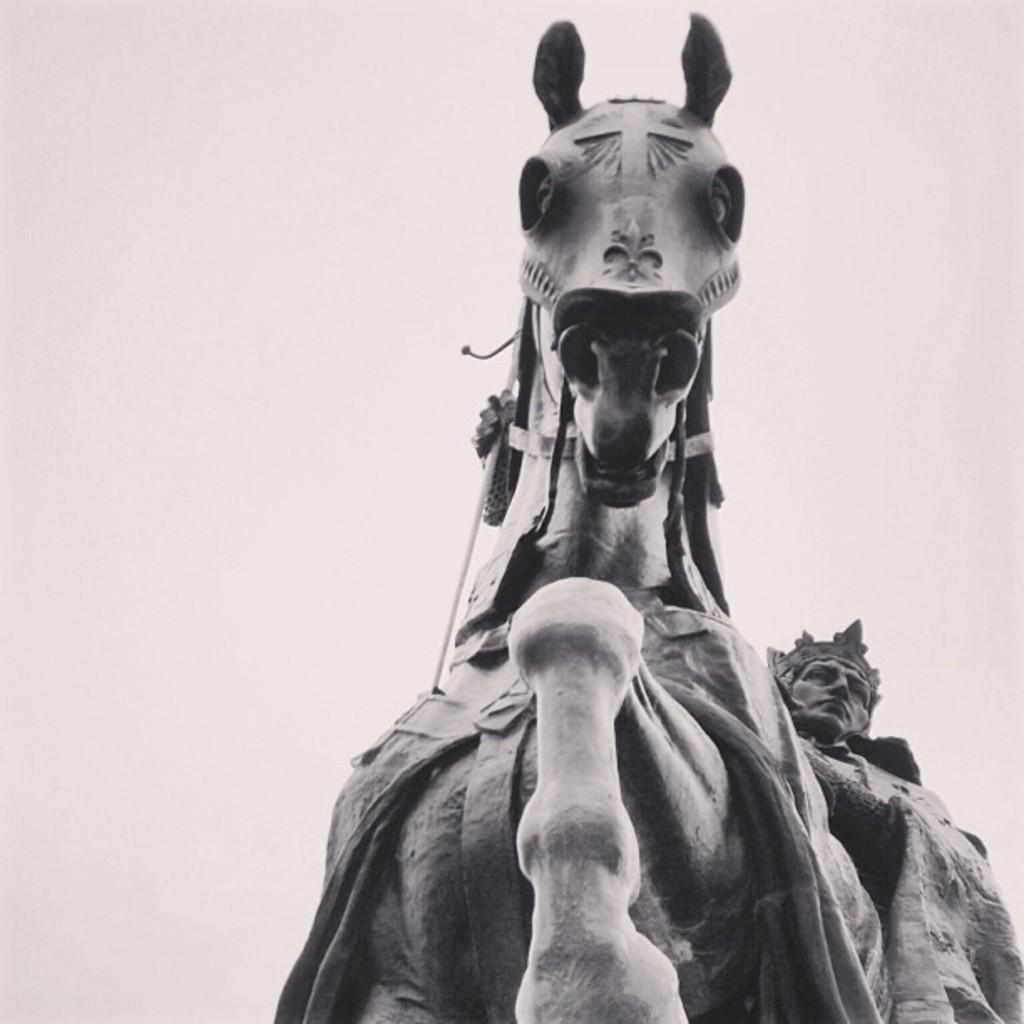Could you give a brief overview of what you see in this image? A black and white picture. A person is sitting on his horse. 